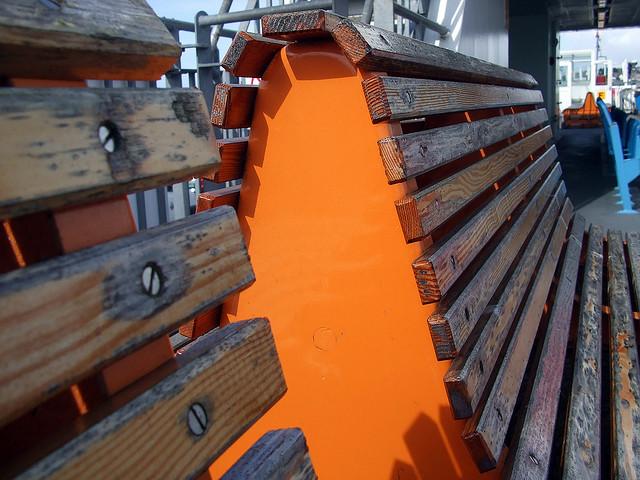Where are these benches at?
Short answer required. Gym. What type of screwdriver would you need to remove those screws?
Quick response, please. Flathead. Is it daytime?
Be succinct. Yes. 